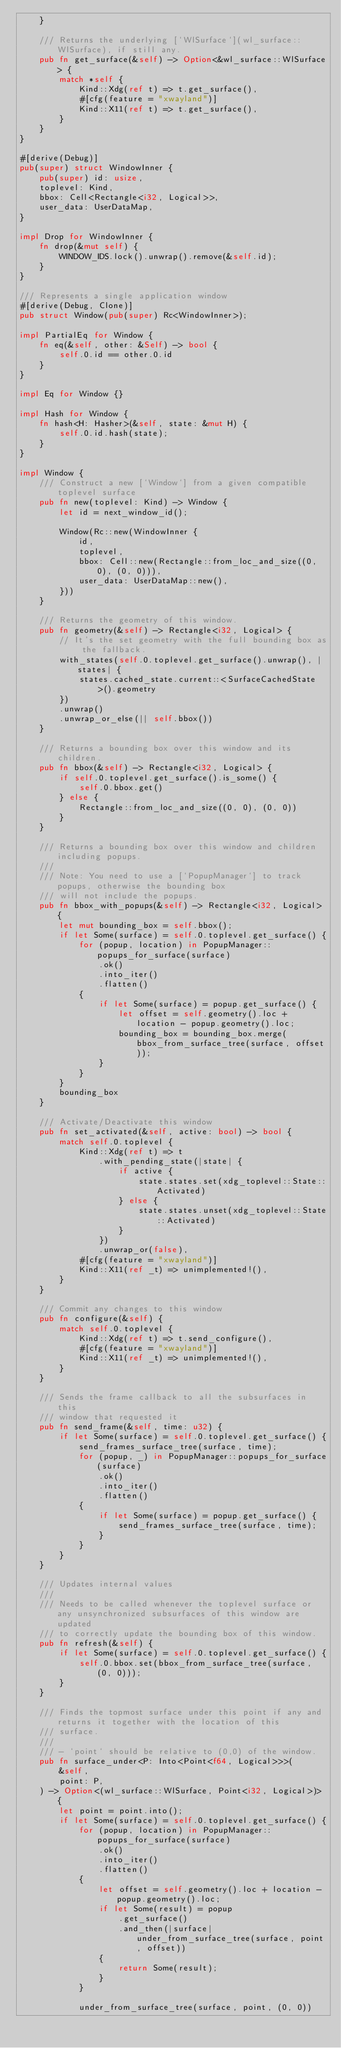<code> <loc_0><loc_0><loc_500><loc_500><_Rust_>    }

    /// Returns the underlying [`WlSurface`](wl_surface::WlSurface), if still any.
    pub fn get_surface(&self) -> Option<&wl_surface::WlSurface> {
        match *self {
            Kind::Xdg(ref t) => t.get_surface(),
            #[cfg(feature = "xwayland")]
            Kind::X11(ref t) => t.get_surface(),
        }
    }
}

#[derive(Debug)]
pub(super) struct WindowInner {
    pub(super) id: usize,
    toplevel: Kind,
    bbox: Cell<Rectangle<i32, Logical>>,
    user_data: UserDataMap,
}

impl Drop for WindowInner {
    fn drop(&mut self) {
        WINDOW_IDS.lock().unwrap().remove(&self.id);
    }
}

/// Represents a single application window
#[derive(Debug, Clone)]
pub struct Window(pub(super) Rc<WindowInner>);

impl PartialEq for Window {
    fn eq(&self, other: &Self) -> bool {
        self.0.id == other.0.id
    }
}

impl Eq for Window {}

impl Hash for Window {
    fn hash<H: Hasher>(&self, state: &mut H) {
        self.0.id.hash(state);
    }
}

impl Window {
    /// Construct a new [`Window`] from a given compatible toplevel surface
    pub fn new(toplevel: Kind) -> Window {
        let id = next_window_id();

        Window(Rc::new(WindowInner {
            id,
            toplevel,
            bbox: Cell::new(Rectangle::from_loc_and_size((0, 0), (0, 0))),
            user_data: UserDataMap::new(),
        }))
    }

    /// Returns the geometry of this window.
    pub fn geometry(&self) -> Rectangle<i32, Logical> {
        // It's the set geometry with the full bounding box as the fallback.
        with_states(self.0.toplevel.get_surface().unwrap(), |states| {
            states.cached_state.current::<SurfaceCachedState>().geometry
        })
        .unwrap()
        .unwrap_or_else(|| self.bbox())
    }

    /// Returns a bounding box over this window and its children.
    pub fn bbox(&self) -> Rectangle<i32, Logical> {
        if self.0.toplevel.get_surface().is_some() {
            self.0.bbox.get()
        } else {
            Rectangle::from_loc_and_size((0, 0), (0, 0))
        }
    }

    /// Returns a bounding box over this window and children including popups.
    ///
    /// Note: You need to use a [`PopupManager`] to track popups, otherwise the bounding box
    /// will not include the popups.
    pub fn bbox_with_popups(&self) -> Rectangle<i32, Logical> {
        let mut bounding_box = self.bbox();
        if let Some(surface) = self.0.toplevel.get_surface() {
            for (popup, location) in PopupManager::popups_for_surface(surface)
                .ok()
                .into_iter()
                .flatten()
            {
                if let Some(surface) = popup.get_surface() {
                    let offset = self.geometry().loc + location - popup.geometry().loc;
                    bounding_box = bounding_box.merge(bbox_from_surface_tree(surface, offset));
                }
            }
        }
        bounding_box
    }

    /// Activate/Deactivate this window
    pub fn set_activated(&self, active: bool) -> bool {
        match self.0.toplevel {
            Kind::Xdg(ref t) => t
                .with_pending_state(|state| {
                    if active {
                        state.states.set(xdg_toplevel::State::Activated)
                    } else {
                        state.states.unset(xdg_toplevel::State::Activated)
                    }
                })
                .unwrap_or(false),
            #[cfg(feature = "xwayland")]
            Kind::X11(ref _t) => unimplemented!(),
        }
    }

    /// Commit any changes to this window
    pub fn configure(&self) {
        match self.0.toplevel {
            Kind::Xdg(ref t) => t.send_configure(),
            #[cfg(feature = "xwayland")]
            Kind::X11(ref _t) => unimplemented!(),
        }
    }

    /// Sends the frame callback to all the subsurfaces in this
    /// window that requested it
    pub fn send_frame(&self, time: u32) {
        if let Some(surface) = self.0.toplevel.get_surface() {
            send_frames_surface_tree(surface, time);
            for (popup, _) in PopupManager::popups_for_surface(surface)
                .ok()
                .into_iter()
                .flatten()
            {
                if let Some(surface) = popup.get_surface() {
                    send_frames_surface_tree(surface, time);
                }
            }
        }
    }

    /// Updates internal values
    ///
    /// Needs to be called whenever the toplevel surface or any unsynchronized subsurfaces of this window are updated
    /// to correctly update the bounding box of this window.
    pub fn refresh(&self) {
        if let Some(surface) = self.0.toplevel.get_surface() {
            self.0.bbox.set(bbox_from_surface_tree(surface, (0, 0)));
        }
    }

    /// Finds the topmost surface under this point if any and returns it together with the location of this
    /// surface.
    ///
    /// - `point` should be relative to (0,0) of the window.
    pub fn surface_under<P: Into<Point<f64, Logical>>>(
        &self,
        point: P,
    ) -> Option<(wl_surface::WlSurface, Point<i32, Logical>)> {
        let point = point.into();
        if let Some(surface) = self.0.toplevel.get_surface() {
            for (popup, location) in PopupManager::popups_for_surface(surface)
                .ok()
                .into_iter()
                .flatten()
            {
                let offset = self.geometry().loc + location - popup.geometry().loc;
                if let Some(result) = popup
                    .get_surface()
                    .and_then(|surface| under_from_surface_tree(surface, point, offset))
                {
                    return Some(result);
                }
            }

            under_from_surface_tree(surface, point, (0, 0))</code> 